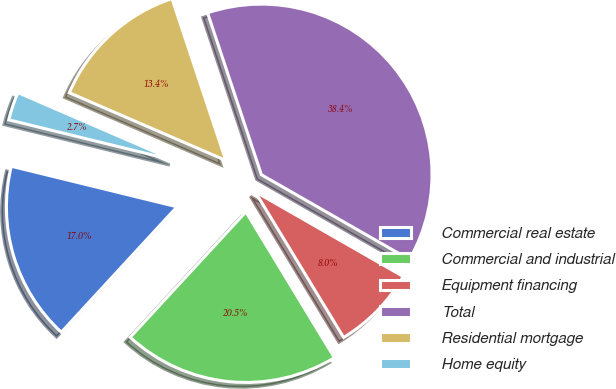Convert chart to OTSL. <chart><loc_0><loc_0><loc_500><loc_500><pie_chart><fcel>Commercial real estate<fcel>Commercial and industrial<fcel>Equipment financing<fcel>Total<fcel>Residential mortgage<fcel>Home equity<nl><fcel>16.96%<fcel>20.54%<fcel>8.04%<fcel>38.39%<fcel>13.39%<fcel>2.68%<nl></chart> 